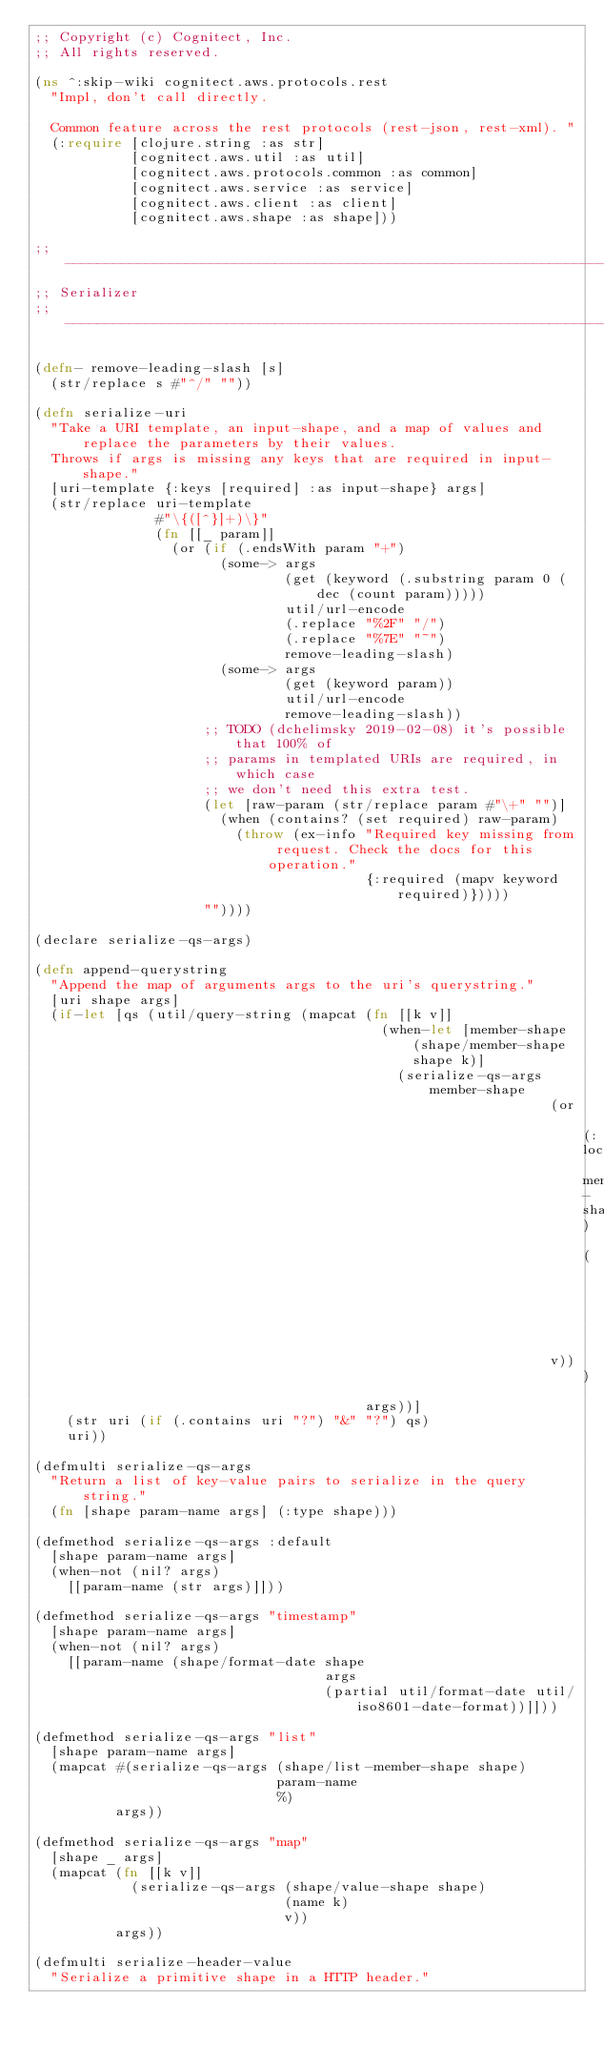Convert code to text. <code><loc_0><loc_0><loc_500><loc_500><_Clojure_>;; Copyright (c) Cognitect, Inc.
;; All rights reserved.

(ns ^:skip-wiki cognitect.aws.protocols.rest
  "Impl, don't call directly.

  Common feature across the rest protocols (rest-json, rest-xml). "
  (:require [clojure.string :as str]
            [cognitect.aws.util :as util]
            [cognitect.aws.protocols.common :as common]
            [cognitect.aws.service :as service]
            [cognitect.aws.client :as client]
            [cognitect.aws.shape :as shape]))

;; ----------------------------------------------------------------------------------------
;; Serializer
;; ----------------------------------------------------------------------------------------

(defn- remove-leading-slash [s]
  (str/replace s #"^/" ""))

(defn serialize-uri
  "Take a URI template, an input-shape, and a map of values and replace the parameters by their values.
  Throws if args is missing any keys that are required in input-shape."
  [uri-template {:keys [required] :as input-shape} args]
  (str/replace uri-template
               #"\{([^}]+)\}"
               (fn [[_ param]]
                 (or (if (.endsWith param "+")
                       (some-> args
                               (get (keyword (.substring param 0 (dec (count param)))))
                               util/url-encode
                               (.replace "%2F" "/")
                               (.replace "%7E" "~")
                               remove-leading-slash)
                       (some-> args
                               (get (keyword param))
                               util/url-encode
                               remove-leading-slash))
                     ;; TODO (dchelimsky 2019-02-08) it's possible that 100% of
                     ;; params in templated URIs are required, in which case
                     ;; we don't need this extra test.
                     (let [raw-param (str/replace param #"\+" "")]
                       (when (contains? (set required) raw-param)
                         (throw (ex-info "Required key missing from request. Check the docs for this operation."
                                         {:required (mapv keyword required)}))))
                     ""))))

(declare serialize-qs-args)

(defn append-querystring
  "Append the map of arguments args to the uri's querystring."
  [uri shape args]
  (if-let [qs (util/query-string (mapcat (fn [[k v]]
                                           (when-let [member-shape (shape/member-shape shape k)]
                                             (serialize-qs-args member-shape
                                                                (or (:locationName member-shape)
                                                                    (name k))
                                                                v)))
                                         args))]
    (str uri (if (.contains uri "?") "&" "?") qs)
    uri))

(defmulti serialize-qs-args
  "Return a list of key-value pairs to serialize in the query string."
  (fn [shape param-name args] (:type shape)))

(defmethod serialize-qs-args :default
  [shape param-name args]
  (when-not (nil? args)
    [[param-name (str args)]]))

(defmethod serialize-qs-args "timestamp"
  [shape param-name args]
  (when-not (nil? args)
    [[param-name (shape/format-date shape
                                    args
                                    (partial util/format-date util/iso8601-date-format))]]))

(defmethod serialize-qs-args "list"
  [shape param-name args]
  (mapcat #(serialize-qs-args (shape/list-member-shape shape)
                              param-name
                              %)
          args))

(defmethod serialize-qs-args "map"
  [shape _ args]
  (mapcat (fn [[k v]]
            (serialize-qs-args (shape/value-shape shape)
                               (name k)
                               v))
          args))

(defmulti serialize-header-value
  "Serialize a primitive shape in a HTTP header."</code> 